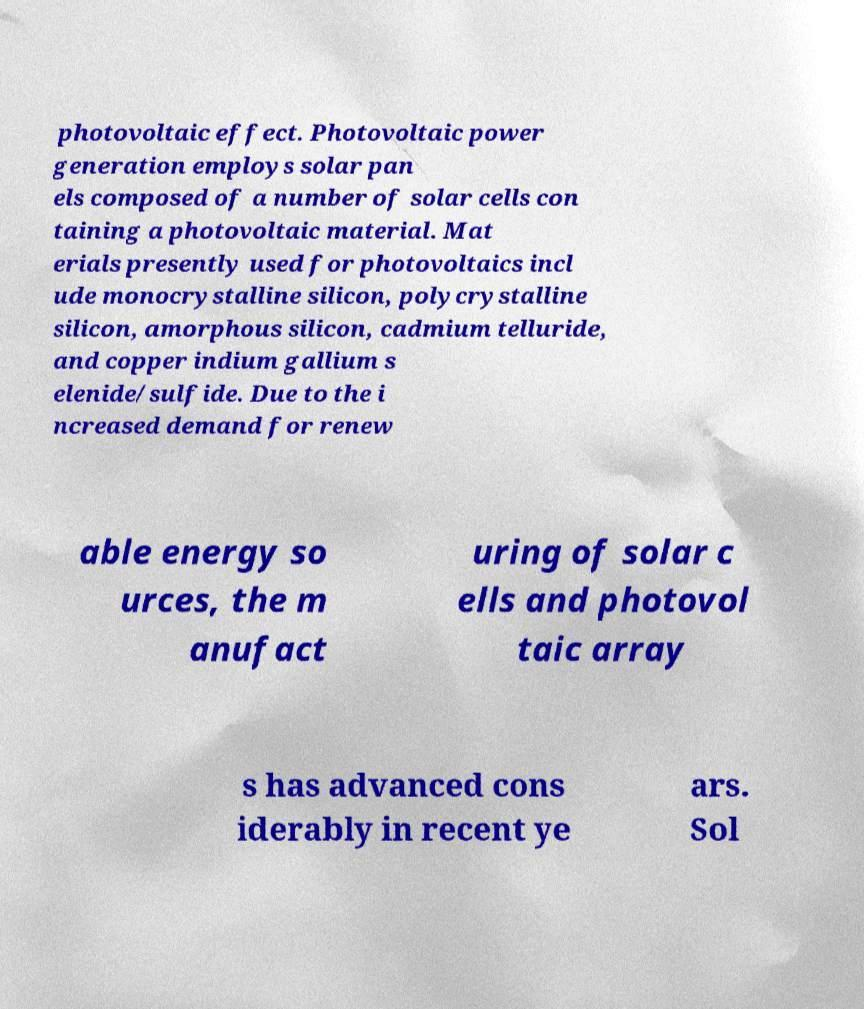I need the written content from this picture converted into text. Can you do that? photovoltaic effect. Photovoltaic power generation employs solar pan els composed of a number of solar cells con taining a photovoltaic material. Mat erials presently used for photovoltaics incl ude monocrystalline silicon, polycrystalline silicon, amorphous silicon, cadmium telluride, and copper indium gallium s elenide/sulfide. Due to the i ncreased demand for renew able energy so urces, the m anufact uring of solar c ells and photovol taic array s has advanced cons iderably in recent ye ars. Sol 